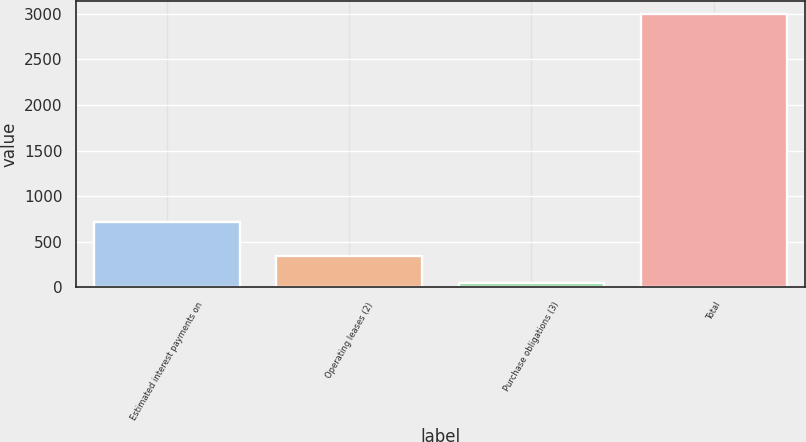<chart> <loc_0><loc_0><loc_500><loc_500><bar_chart><fcel>Estimated interest payments on<fcel>Operating leases (2)<fcel>Purchase obligations (3)<fcel>Total<nl><fcel>719.1<fcel>340.09<fcel>45.5<fcel>2991.4<nl></chart> 